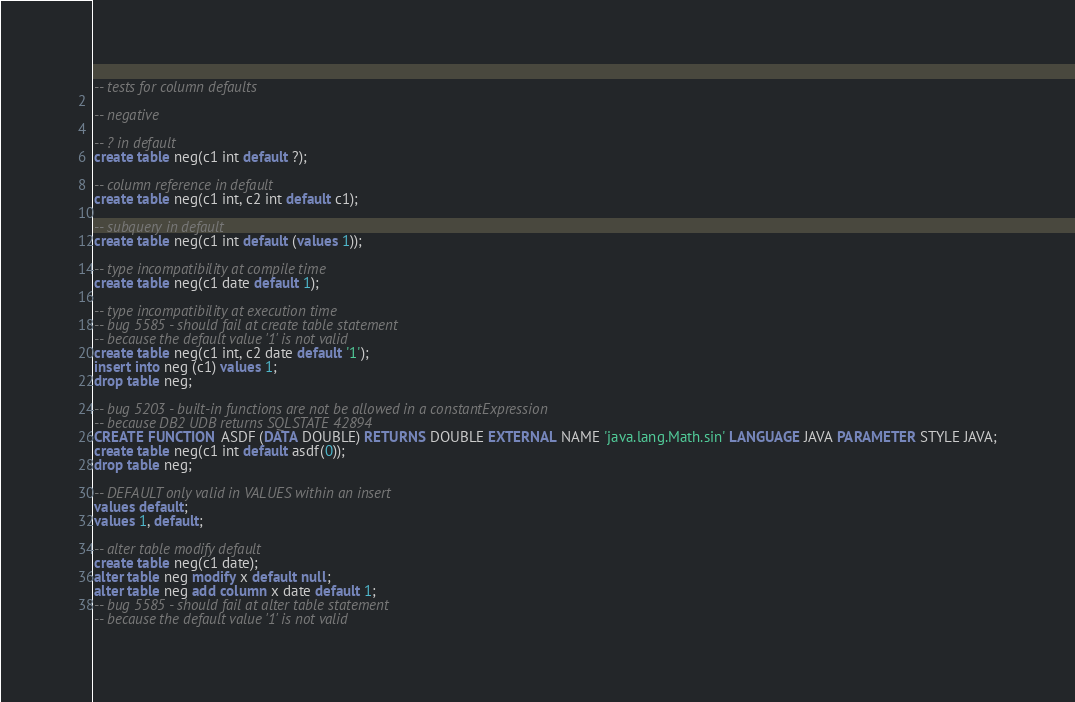Convert code to text. <code><loc_0><loc_0><loc_500><loc_500><_SQL_>-- tests for column defaults

-- negative

-- ? in default
create table neg(c1 int default ?);

-- column reference in default
create table neg(c1 int, c2 int default c1);

-- subquery in default
create table neg(c1 int default (values 1));

-- type incompatibility at compile time
create table neg(c1 date default 1);

-- type incompatibility at execution time
-- bug 5585 - should fail at create table statement
-- because the default value '1' is not valid
create table neg(c1 int, c2 date default '1');
insert into neg (c1) values 1;
drop table neg;

-- bug 5203 - built-in functions are not be allowed in a constantExpression
-- because DB2 UDB returns SQLSTATE 42894
CREATE FUNCTION ASDF (DATA DOUBLE) RETURNS DOUBLE EXTERNAL NAME 'java.lang.Math.sin' LANGUAGE JAVA PARAMETER STYLE JAVA;
create table neg(c1 int default asdf(0));
drop table neg;

-- DEFAULT only valid in VALUES within an insert
values default;
values 1, default;

-- alter table modify default
create table neg(c1 date);
alter table neg modify x default null;
alter table neg add column x date default 1;
-- bug 5585 - should fail at alter table statement
-- because the default value '1' is not valid</code> 